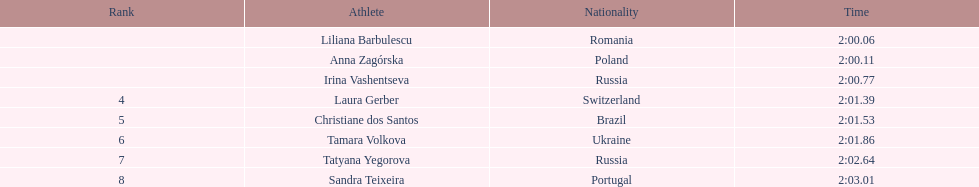Which country had the most finishers in the top 8? Russia. 